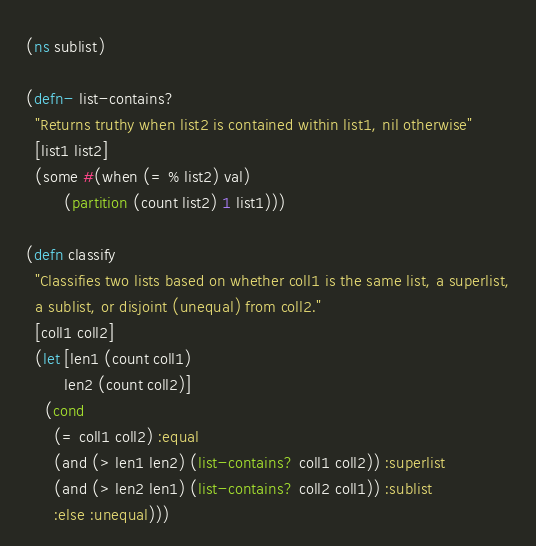<code> <loc_0><loc_0><loc_500><loc_500><_Clojure_>(ns sublist)

(defn- list-contains?
  "Returns truthy when list2 is contained within list1, nil otherwise"
  [list1 list2]
  (some #(when (= % list2) val)
        (partition (count list2) 1 list1)))

(defn classify
  "Classifies two lists based on whether coll1 is the same list, a superlist,
  a sublist, or disjoint (unequal) from coll2."
  [coll1 coll2]
  (let [len1 (count coll1)
        len2 (count coll2)]
    (cond
      (= coll1 coll2) :equal
      (and (> len1 len2) (list-contains? coll1 coll2)) :superlist
      (and (> len2 len1) (list-contains? coll2 coll1)) :sublist
      :else :unequal)))
</code> 